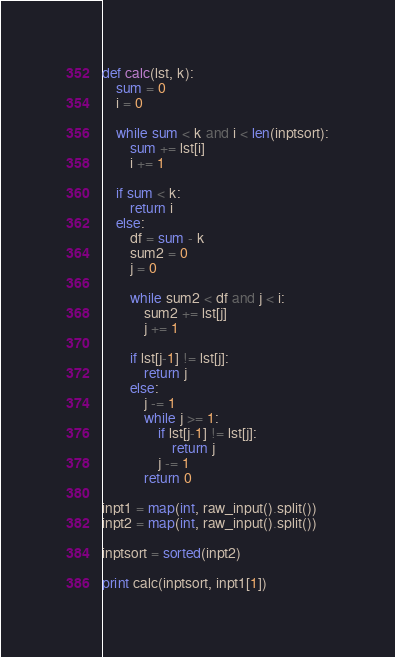<code> <loc_0><loc_0><loc_500><loc_500><_Python_>def calc(lst, k):
	sum = 0
	i = 0
	
	while sum < k and i < len(inptsort):
		sum += lst[i]
		i += 1
	
	if sum < k:
		return i
	else:
		df = sum - k
		sum2 = 0
		j = 0
		
		while sum2 < df and j < i:
			sum2 += lst[j]
			j += 1
		
		if lst[j-1] != lst[j]:
			return j
		else:
			j -= 1
			while j >= 1:
				if lst[j-1] != lst[j]:
					return j
				j -= 1
			return 0

inpt1 = map(int, raw_input().split())
inpt2 = map(int, raw_input().split())

inptsort = sorted(inpt2)

print calc(inptsort, inpt1[1])</code> 